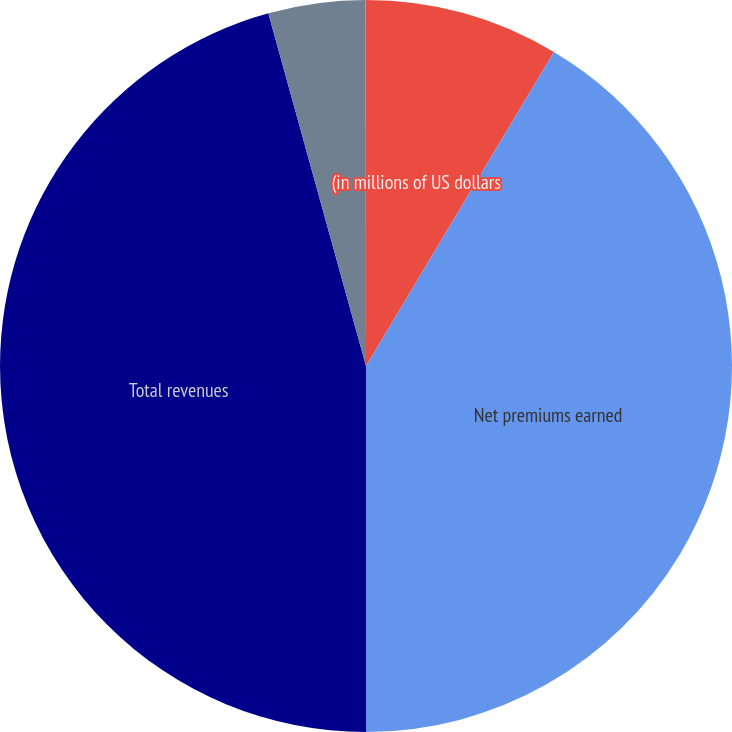<chart> <loc_0><loc_0><loc_500><loc_500><pie_chart><fcel>(in millions of US dollars<fcel>Net premiums earned<fcel>Total revenues<fcel>Net income<fcel>Diluted earnings per share<nl><fcel>8.58%<fcel>41.42%<fcel>45.7%<fcel>4.29%<fcel>0.01%<nl></chart> 